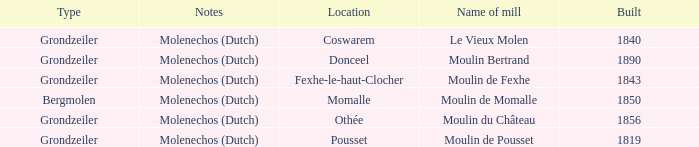What is the Location of the Moulin Bertrand Mill? Donceel. 